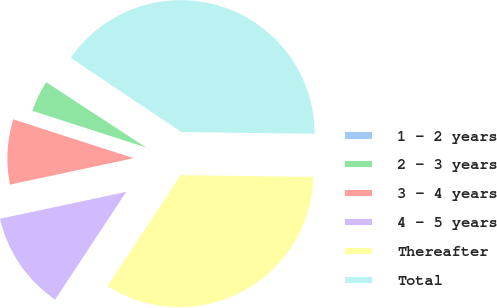Convert chart. <chart><loc_0><loc_0><loc_500><loc_500><pie_chart><fcel>1 - 2 years<fcel>2 - 3 years<fcel>3 - 4 years<fcel>4 - 5 years<fcel>Thereafter<fcel>Total<nl><fcel>0.18%<fcel>4.25%<fcel>8.31%<fcel>12.37%<fcel>34.08%<fcel>40.81%<nl></chart> 